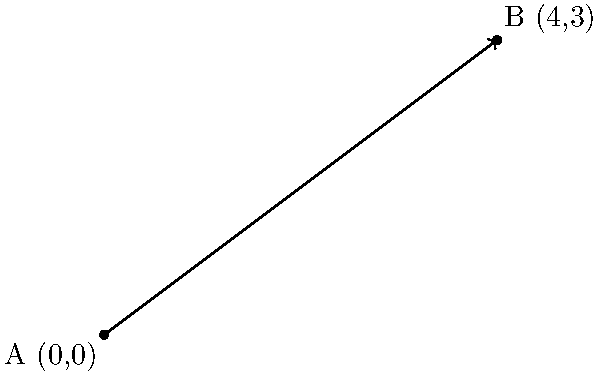In a recording studio, two microphones are positioned at points A(0,0) and B(4,3) on a coordinate plane, where each unit represents 1 meter. As the audiobook narrator, you need to calculate the exact distance between these microphones to ensure optimal sound quality. What is the distance between the two microphones in meters? To find the distance between two points in a coordinate plane, we can use the distance formula:

$$d = \sqrt{(x_2 - x_1)^2 + (y_2 - y_1)^2}$$

Where $(x_1, y_1)$ are the coordinates of point A and $(x_2, y_2)$ are the coordinates of point B.

Given:
Point A: $(0, 0)$
Point B: $(4, 3)$

Let's substitute these values into the formula:

$$d = \sqrt{(4 - 0)^2 + (3 - 0)^2}$$

Simplify:
$$d = \sqrt{4^2 + 3^2}$$
$$d = \sqrt{16 + 9}$$
$$d = \sqrt{25}$$
$$d = 5$$

Therefore, the distance between the two microphones is 5 meters.
Answer: 5 meters 